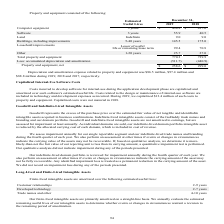According to Godaddy's financial document, What is the useful life of computer equipment? According to the financial document, 3 years. The relevant text states: "l Lives December 31, 2019 2018 Computer equipment 3 years $ 434.8 $ 417.6 Software 3 years 55.9 40.5 Land Indefinite 9.0 9.0 Buildings, including improvement..." Also, What is the useful life of land? According to the financial document, Indefinite. The relevant text states: "s $ 434.8 $ 417.6 Software 3 years 55.9 40.5 Land Indefinite 9.0 9.0 Buildings, including improvements 5-40 years 145.5 175.0 Leasehold improvements Lesser of u..." Also, What is the useful life of buildings, including improvements? According to the financial document, 5-40 years. The relevant text states: "efinite 9.0 9.0 Buildings, including improvements 5-40 years 145.5 175.0 Leasehold improvements Lesser of useful life or remaining lease term 99.4 70.8 Other 1-..." Also, can you calculate: What is the 2019 accumulated depreciation and amortization expense excluding the property and equipment depreciation and amortization expense? Based on the calculation: -511.7+86.5, the result is -425.2 (in millions). This is based on the information: "Less: accumulated depreciation and amortization (511.7) (440.9) Property and equipment, net $ 258.6 $ 299.0 on expense related to property and equipment was $86.5 million, $97.4 million and $88.8 mill..." The key data points involved are: 511.7, 86.5. Also, can you calculate: What is the 2018 accumulated depreciation and amortization expense excluding the property and equipment depreciation and amortization expense? Based on the calculation: -440.9+97.4, the result is -343.5 (in millions). This is based on the information: "ccumulated depreciation and amortization (511.7) (440.9) Property and equipment, net $ 258.6 $ 299.0 ted to property and equipment was $86.5 million, $97.4 million and $88.8 million during 2019, 2018 ..." The key data points involved are: 440.9, 97.4. Additionally, Between 2018 and 2019 year end, which year had more total property and equipment? According to the financial document, 2019. The relevant text states: "Estimated Useful Lives December 31, 2019 2018 Computer equipment 3 years $ 434.8 $ 417.6 Software 3 years 55.9 40.5 Land Indefinite 9.0 9.0..." 